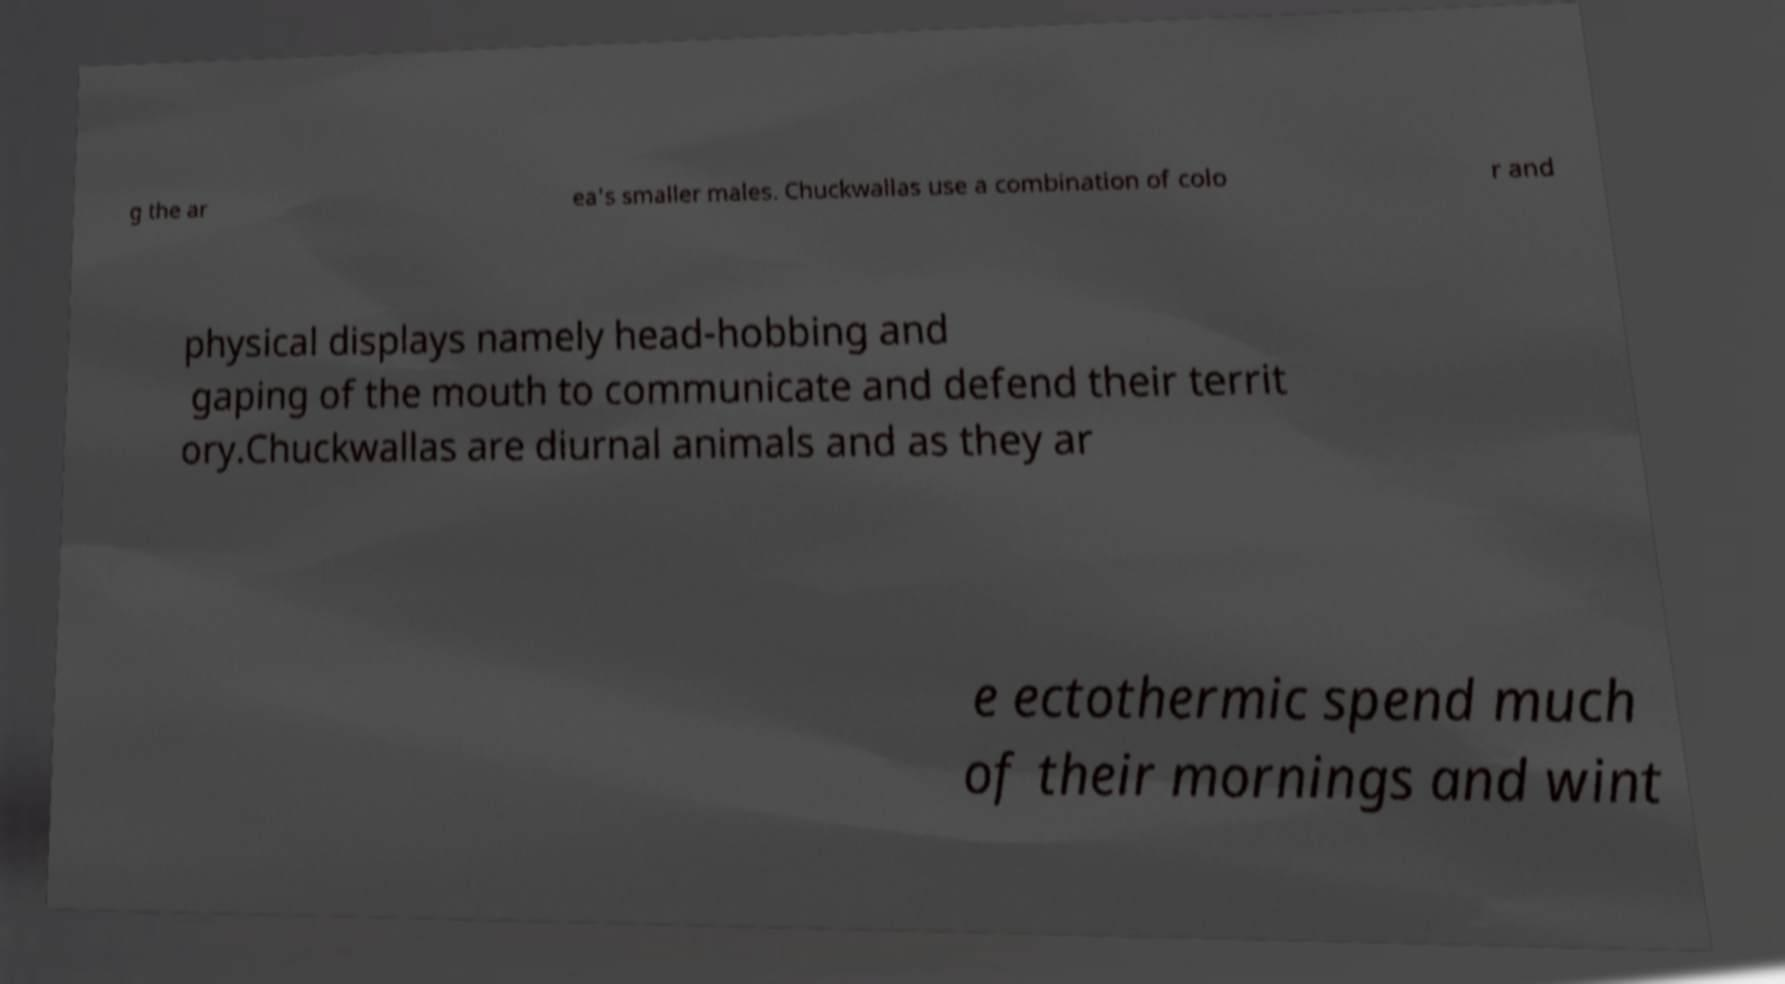Can you read and provide the text displayed in the image?This photo seems to have some interesting text. Can you extract and type it out for me? g the ar ea's smaller males. Chuckwallas use a combination of colo r and physical displays namely head-hobbing and gaping of the mouth to communicate and defend their territ ory.Chuckwallas are diurnal animals and as they ar e ectothermic spend much of their mornings and wint 